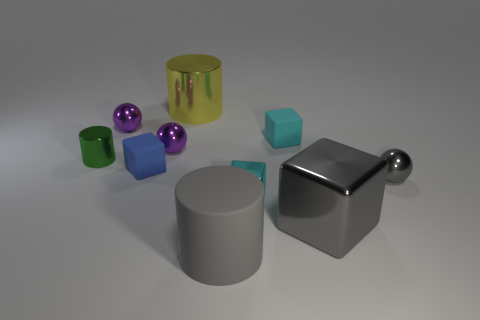Subtract all balls. How many objects are left? 7 Add 8 small cyan things. How many small cyan things are left? 10 Add 6 tiny green cylinders. How many tiny green cylinders exist? 7 Subtract 0 blue spheres. How many objects are left? 10 Subtract all small brown metal cylinders. Subtract all purple things. How many objects are left? 8 